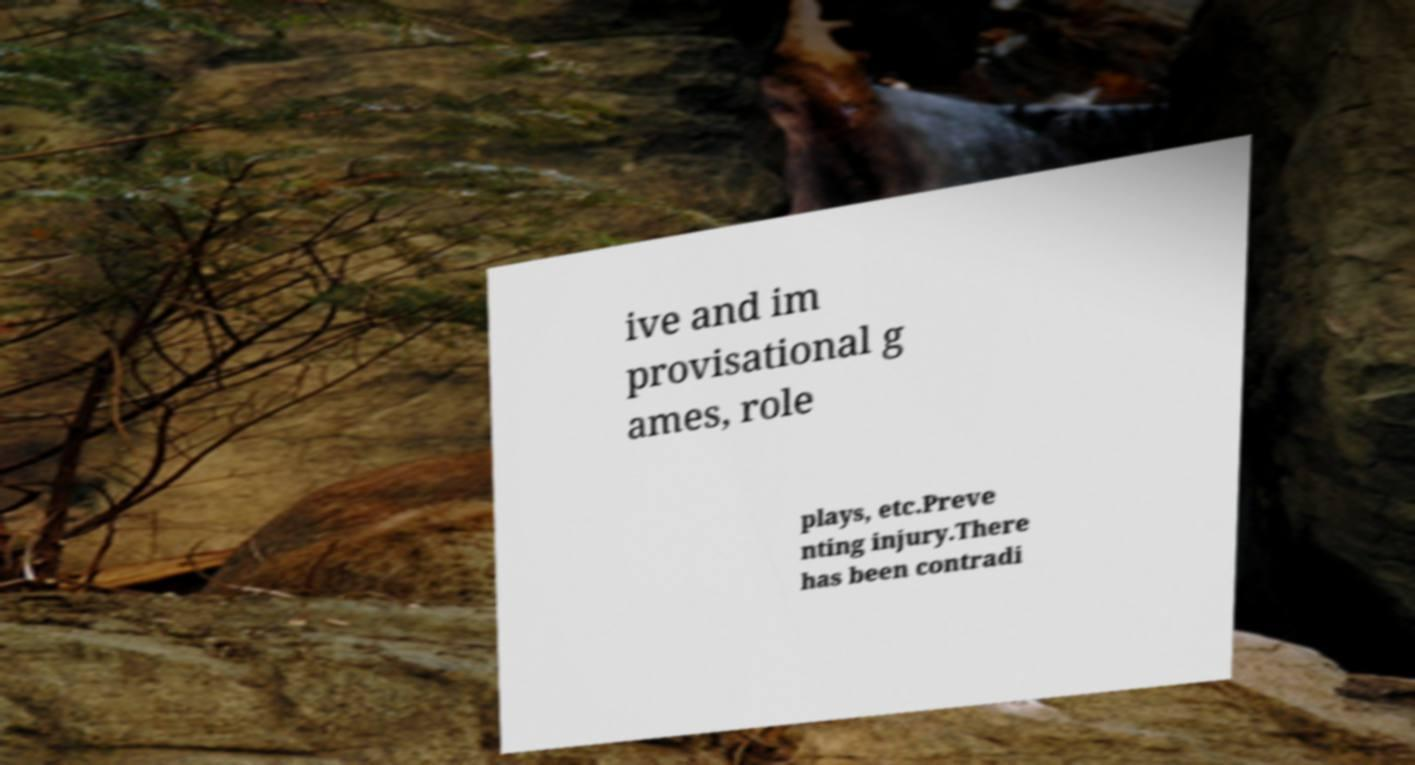Can you accurately transcribe the text from the provided image for me? ive and im provisational g ames, role plays, etc.Preve nting injury.There has been contradi 